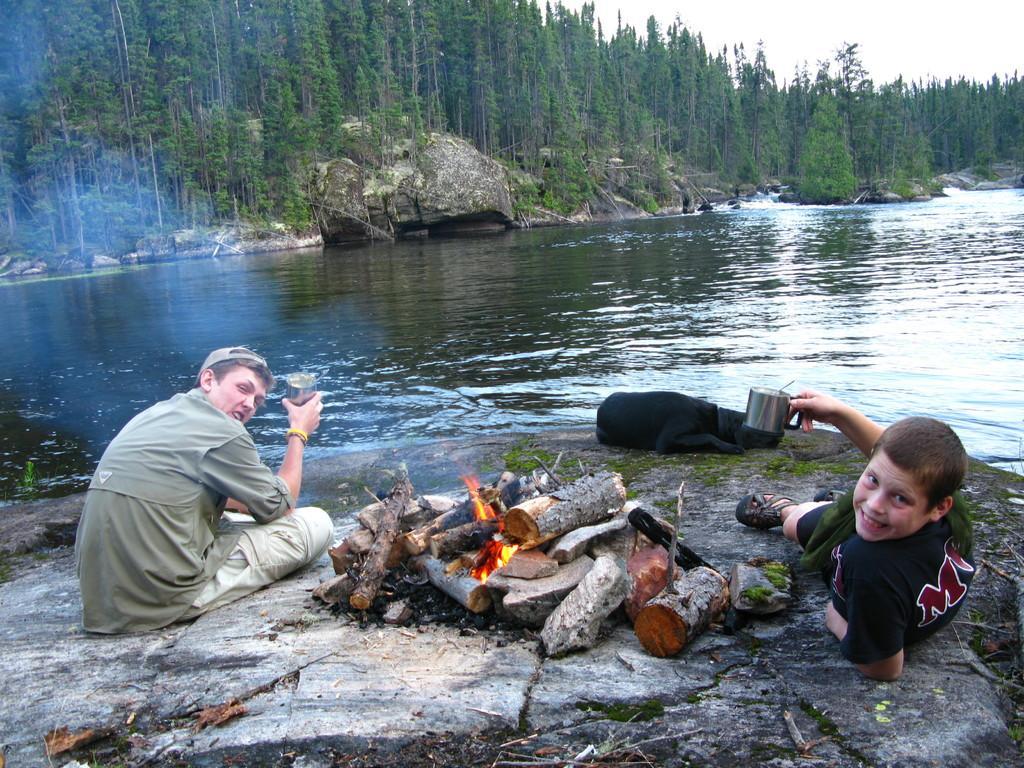How would you summarize this image in a sentence or two? In the image there are two boys sitting and laying around campfire on a rock, in the front there is a lake with trees behind it all over the place and above its sky. 